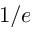<formula> <loc_0><loc_0><loc_500><loc_500>1 / e</formula> 